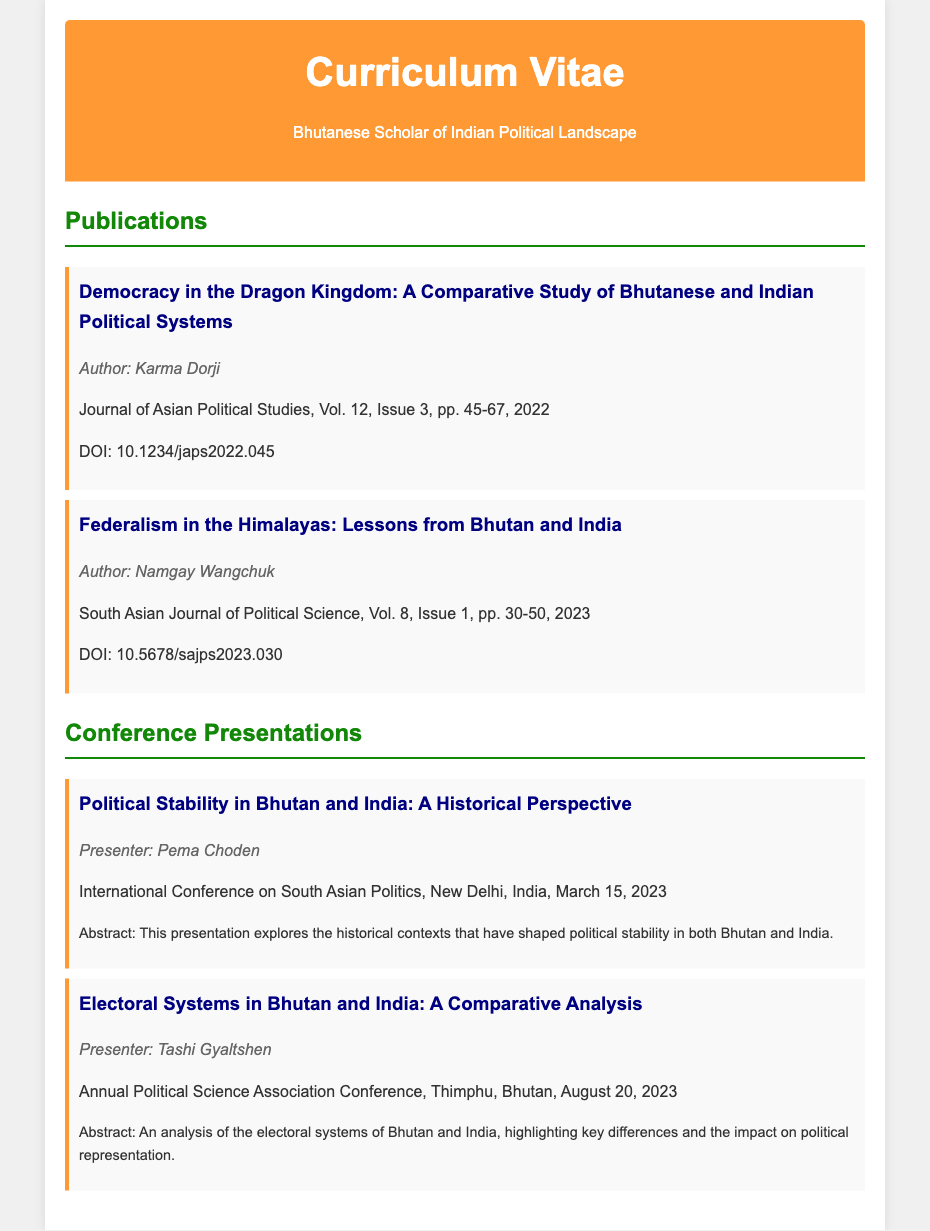What is the title of the publication by Karma Dorji? The document lists the publication title, which is "Democracy in the Dragon Kingdom: A Comparative Study of Bhutanese and Indian Political Systems."
Answer: Democracy in the Dragon Kingdom: A Comparative Study of Bhutanese and Indian Political Systems Who is the author of the publication that discusses federalism? The document identifies Namgay Wangchuk as the author of the publication discussing federalism.
Answer: Namgay Wangchuk In what year was the conference presentation on political stability given? The document states that the presentation on political stability was given on March 15, 2023.
Answer: 2023 What is the DOI of the publication by Namgay Wangchuk? The document provides the DOI for Namgay Wangchuk's publication, which is 10.5678/sajps2023.030.
Answer: 10.5678/sajps2023.030 What is the main topic of Tashi Gyaltshen's presentation? The document describes the main topic of Tashi Gyaltshen’s presentation as "Electoral Systems in Bhutan and India: A Comparative Analysis."
Answer: Electoral Systems in Bhutan and India: A Comparative Analysis How many publications are listed in the document? The document lists a total of two publications.
Answer: 2 Which institution hosted the conference where Pema Choden presented? The document indicates that the International Conference on South Asian Politics was hosted in New Delhi, India.
Answer: New Delhi, India What is the volume and issue number of Karma Dorji's publication? The document specifies that Karma Dorji's publication is in Volume 12, Issue 3.
Answer: Volume 12, Issue 3 